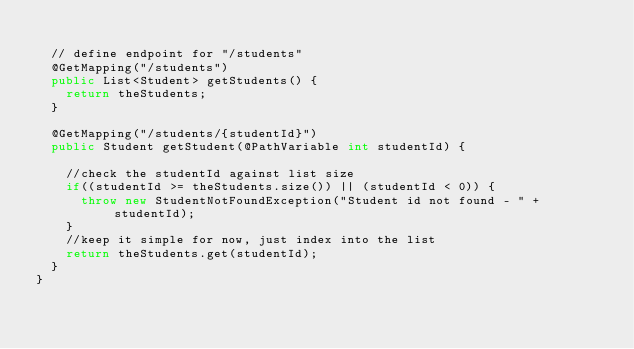<code> <loc_0><loc_0><loc_500><loc_500><_Java_>	
	// define endpoint for "/students" 
	@GetMapping("/students")
	public List<Student> getStudents() {
		return theStudents;
	}
	
	@GetMapping("/students/{studentId}")
	public Student getStudent(@PathVariable int studentId) {
		
		//check the studentId against list size
		if((studentId >= theStudents.size()) || (studentId < 0)) {
			throw new StudentNotFoundException("Student id not found - " + studentId);
		}
		//keep it simple for now, just index into the list
		return theStudents.get(studentId);
	}
}
</code> 